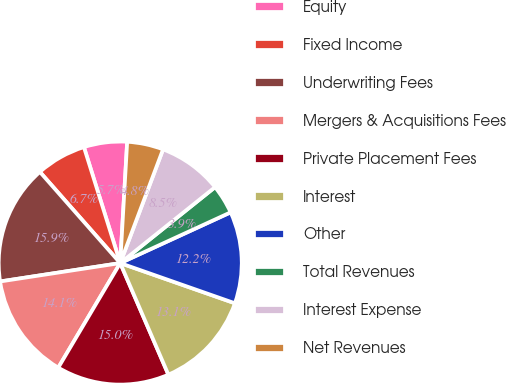Convert chart. <chart><loc_0><loc_0><loc_500><loc_500><pie_chart><fcel>Equity<fcel>Fixed Income<fcel>Underwriting Fees<fcel>Mergers & Acquisitions Fees<fcel>Private Placement Fees<fcel>Interest<fcel>Other<fcel>Total Revenues<fcel>Interest Expense<fcel>Net Revenues<nl><fcel>5.74%<fcel>6.67%<fcel>15.92%<fcel>14.07%<fcel>15.0%<fcel>13.15%<fcel>12.22%<fcel>3.89%<fcel>8.52%<fcel>4.82%<nl></chart> 